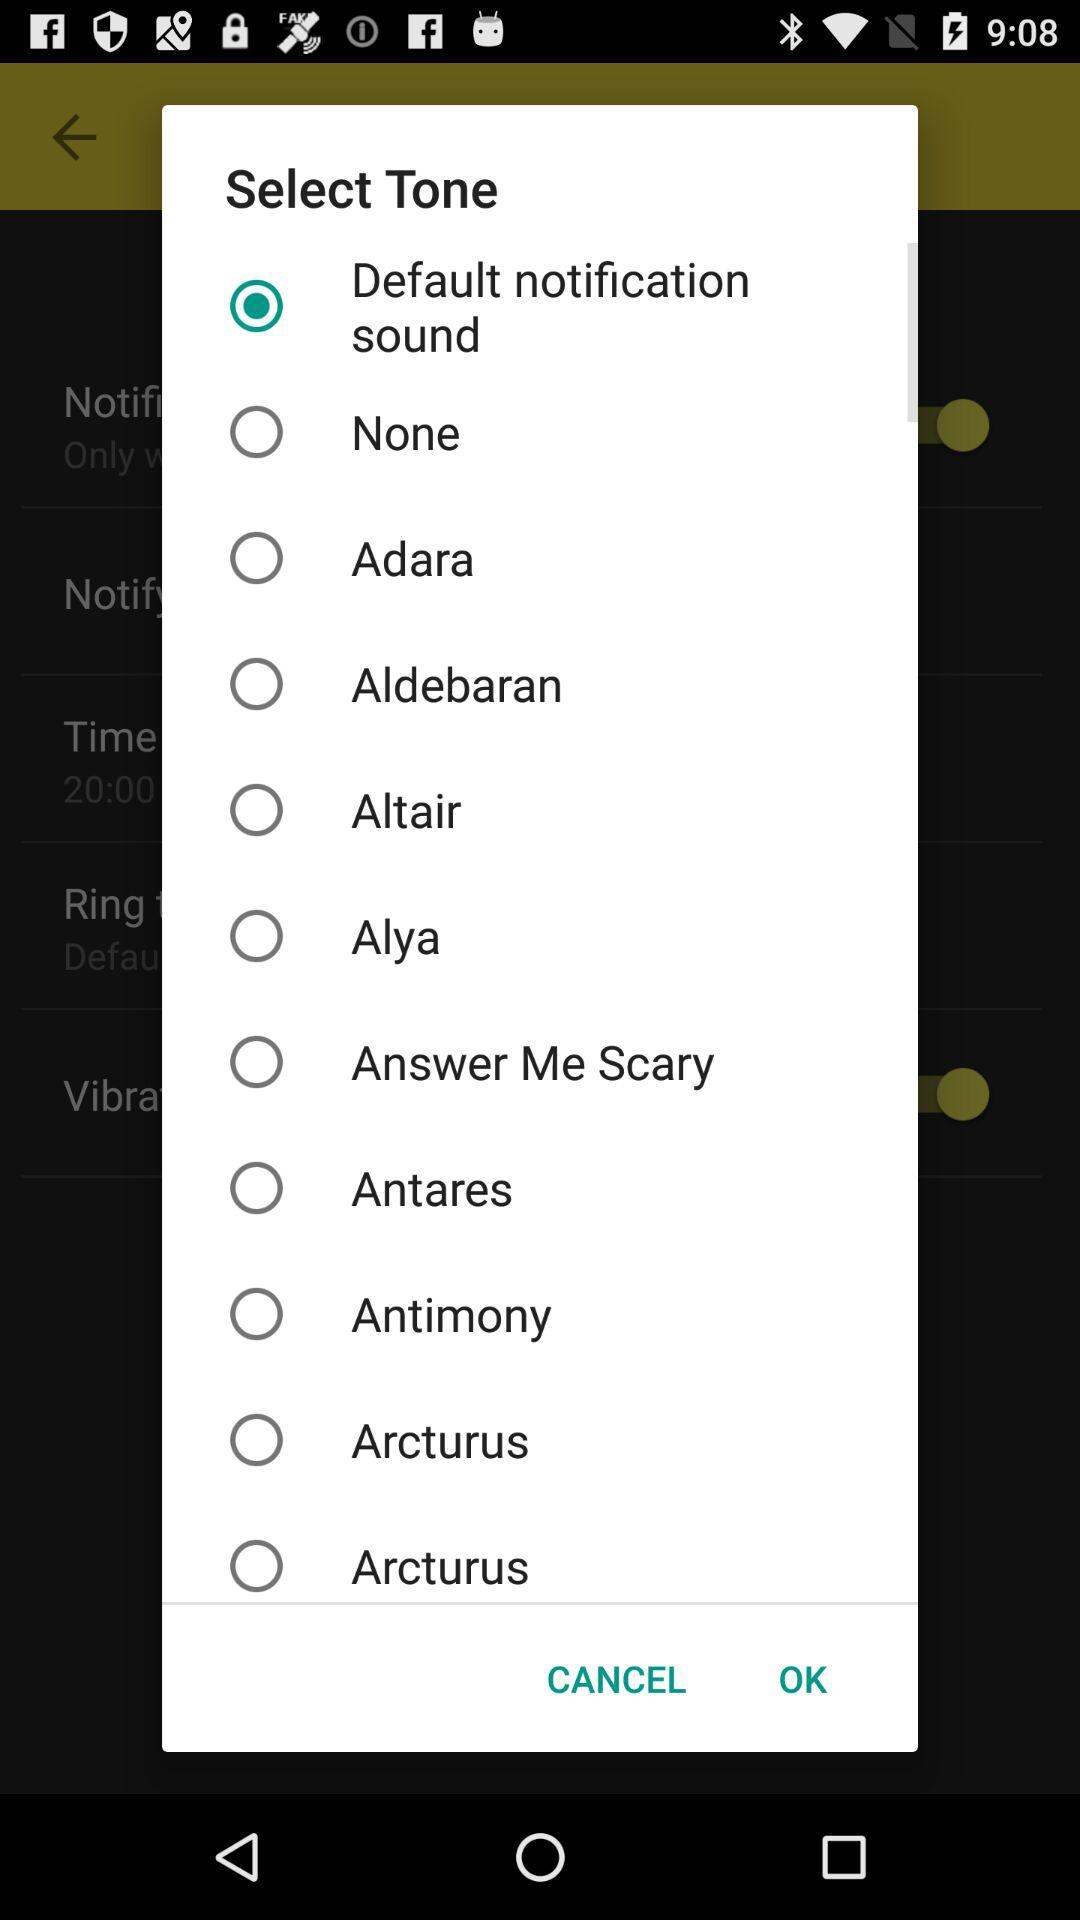Which option is selected? The selected option is "Default notification sound". 